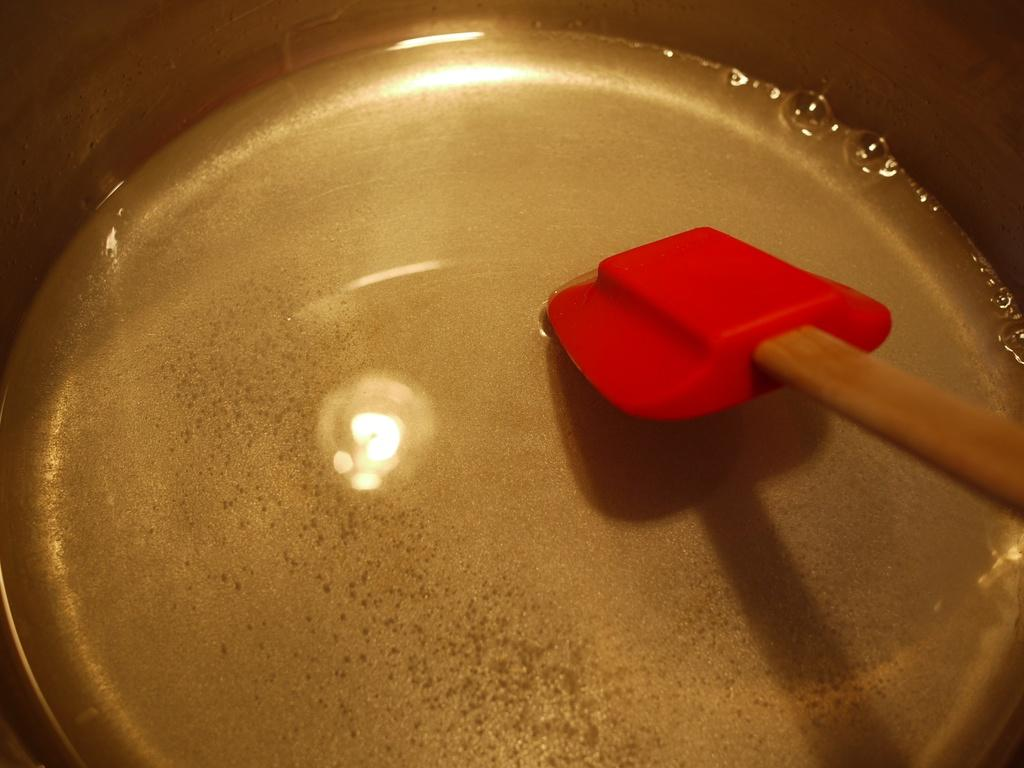What is located in the bowl in the image? There is water in the bowl in the image. What object is placed in the water? There is a spoon in the bowl. Can you describe the appearance of the water in the bowl? The water in the bowl has a reflection of light on it. How does the chin of the person in the image affect the water's surface tension? There is no person present in the image, so their chin cannot affect the water's surface tension. 